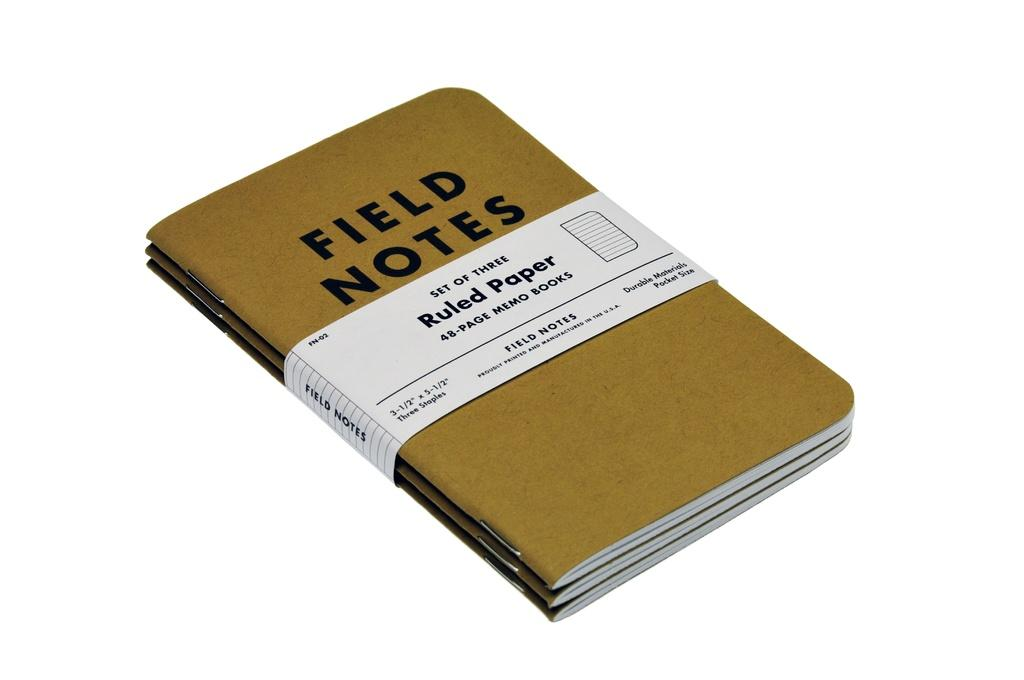<image>
Give a short and clear explanation of the subsequent image. Book of Field Notes set of three ruled paper. 